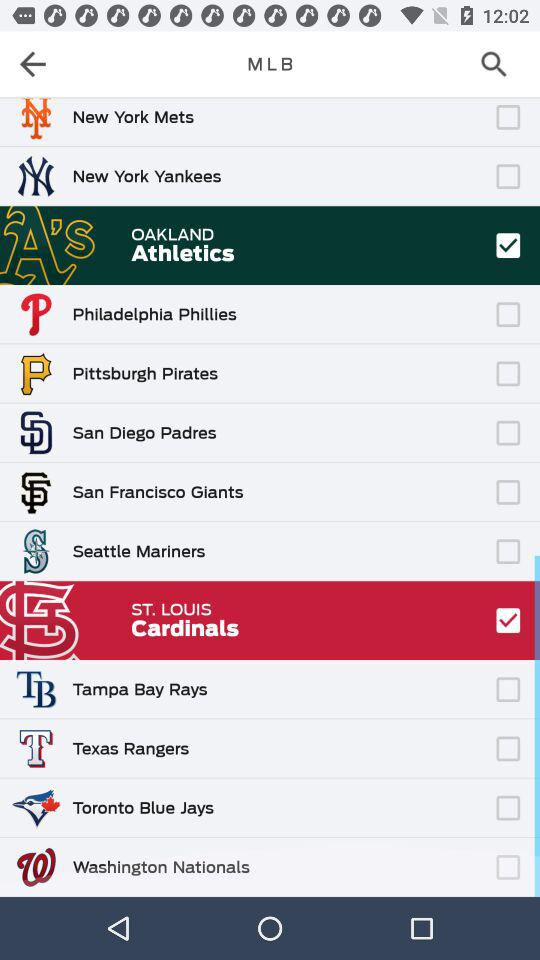Which teams are checked? The checked teams are "OAKLAND Athletics" and "ST. LOUIS Cardinals". 